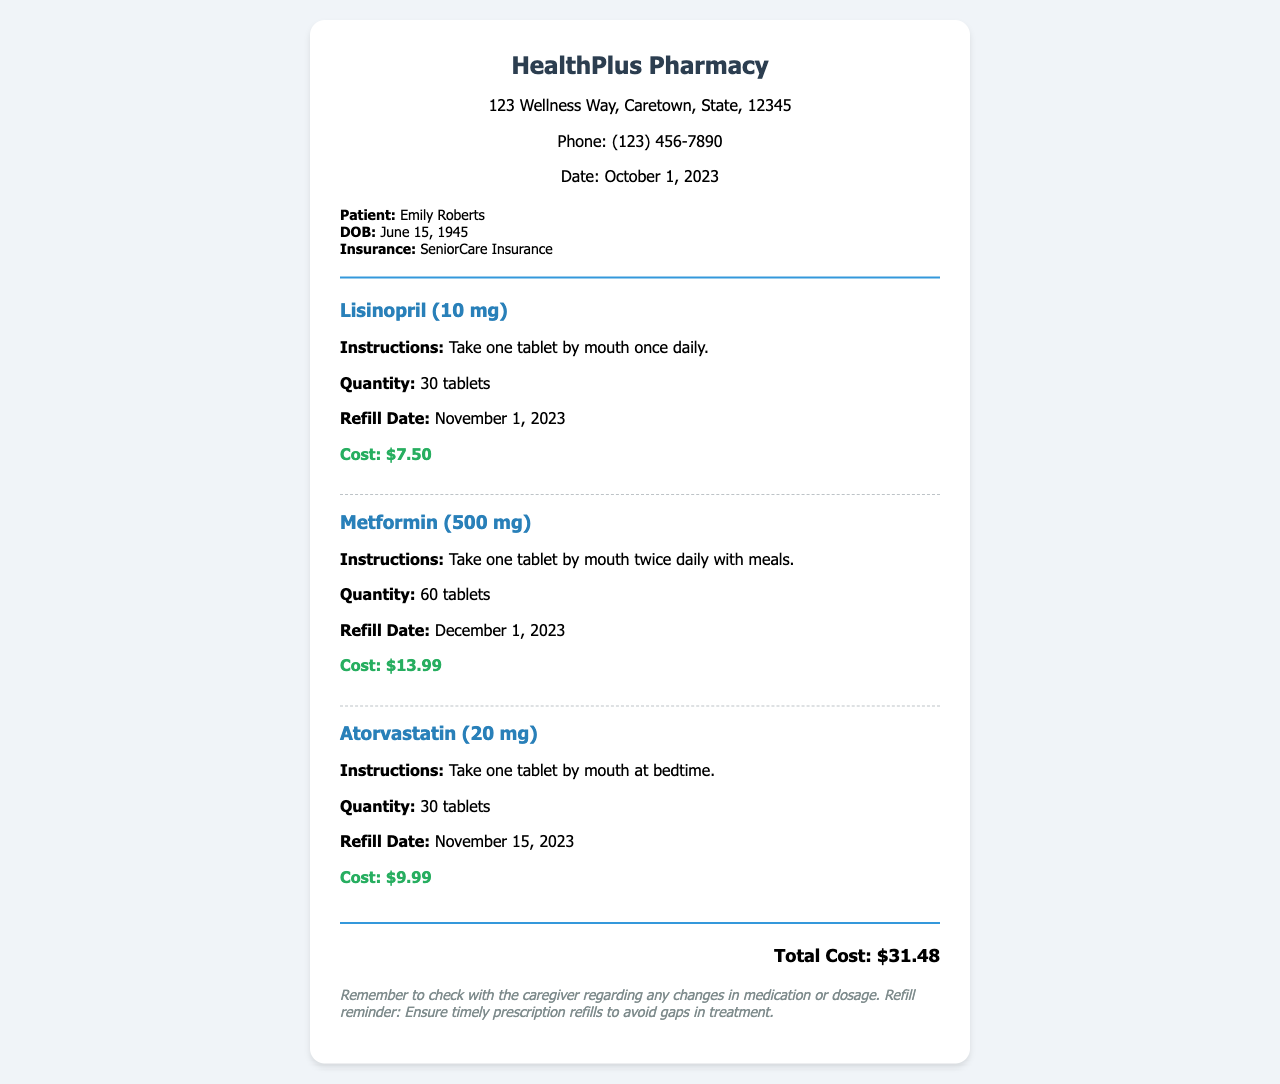What is the total cost of the medications? The total cost is stated at the bottom of the receipt, which sums up all individual medication costs.
Answer: $31.48 Who is the patient? The document specifies the name of the patient in the patient info section.
Answer: Emily Roberts What is the refill date for Lisinopril? The refill date for Lisinopril is mentioned in the medication details.
Answer: November 1, 2023 How many tablets of Metformin are prescribed? The quantity of Metformin prescribed is detailed in the medication segment.
Answer: 60 tablets What are the dosage instructions for Atorvastatin? The instructions for Atorvastatin can be found within the medication section detailing how it should be taken.
Answer: Take one tablet by mouth at bedtime What is the quantity of Lisinopril? The quantity of Lisinopril is listed under its specific medication details on the receipt.
Answer: 30 tablets How much does the Metformin cost? The cost of Metformin is explicitly stated in the medication description.
Answer: $13.99 What is the phone number of HealthPlus Pharmacy? The phone number can be found at the top of the receipt under the pharmacy information.
Answer: (123) 456-7890 What is the insurance provider for the patient? The insurance provider is listed in the patient information section of the receipt.
Answer: SeniorCare Insurance 